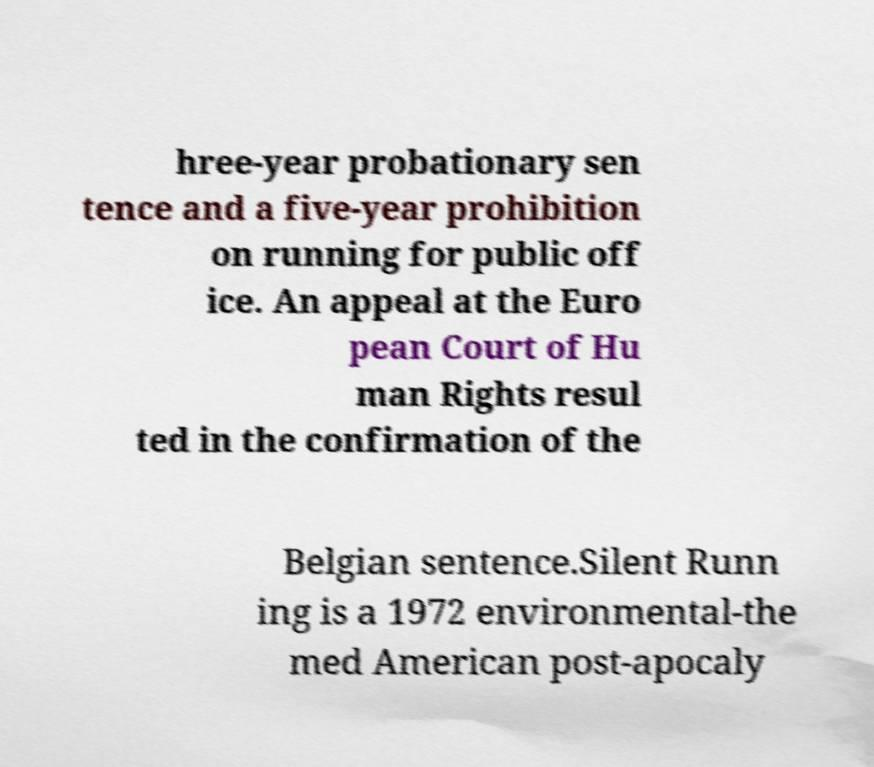Please read and relay the text visible in this image. What does it say? hree-year probationary sen tence and a five-year prohibition on running for public off ice. An appeal at the Euro pean Court of Hu man Rights resul ted in the confirmation of the Belgian sentence.Silent Runn ing is a 1972 environmental-the med American post-apocaly 